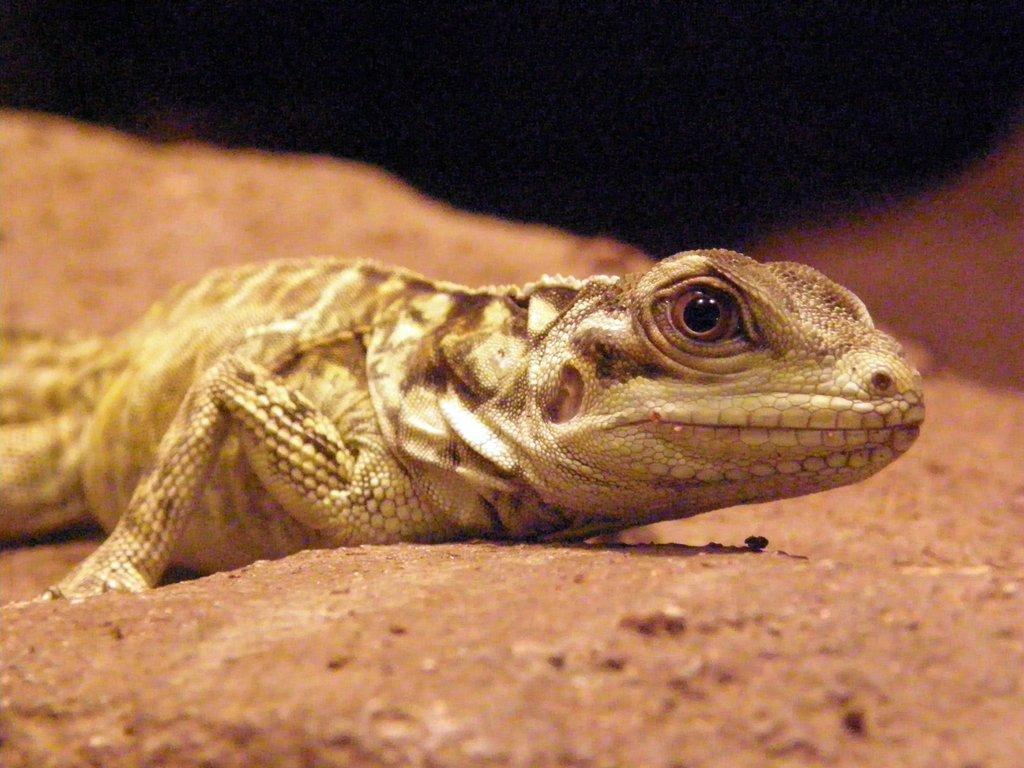What type of animal is in the image? There is a frog in the image. What colors can be seen on the frog? The frog is brown and cream in color. What is the frog resting on in the image? The frog is on a brown-colored surface. Are there any fairies flying around the frog in the image? There are no fairies present in the image; it only features a frog on a brown-colored surface. What type of fabric is the frog sitting on in the image? The image does not provide information about the material of the surface the frog is resting on, only its color. 